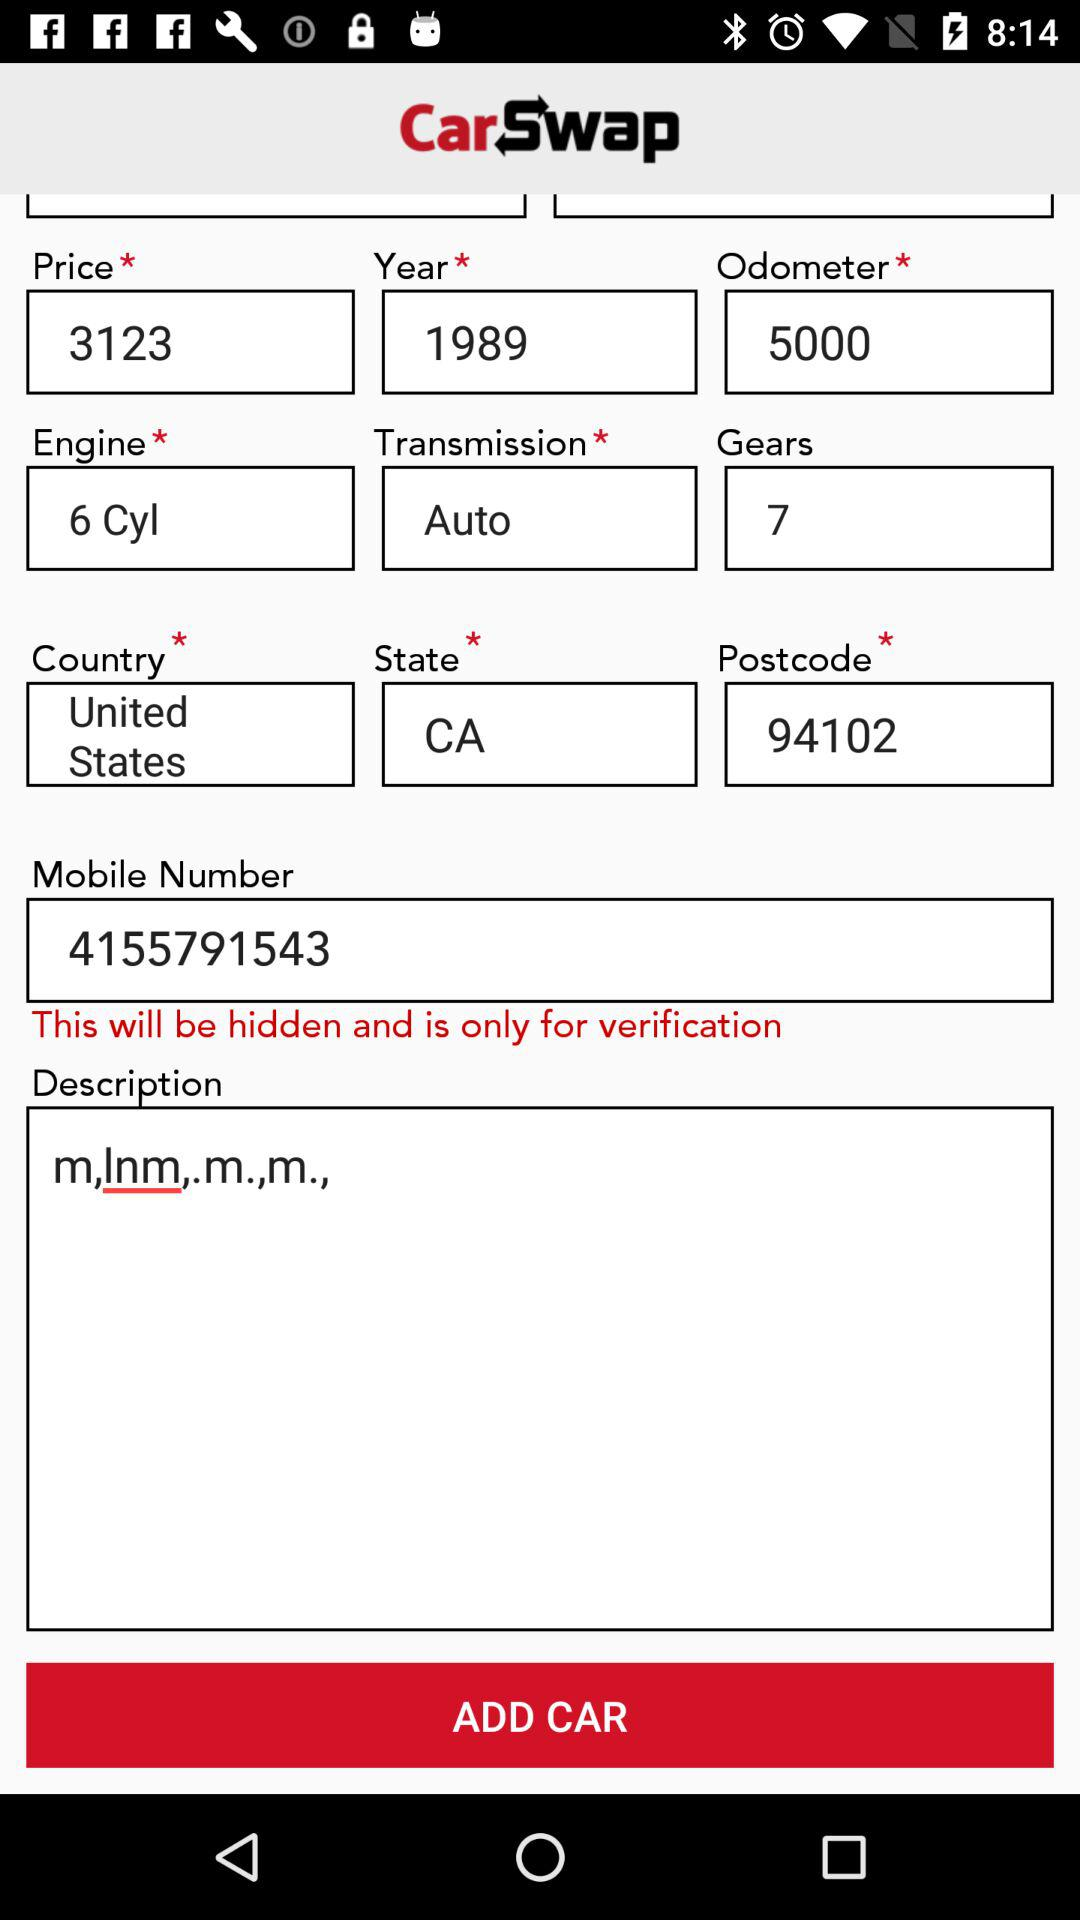What is the engine number?
When the provided information is insufficient, respond with <no answer>. <no answer> 